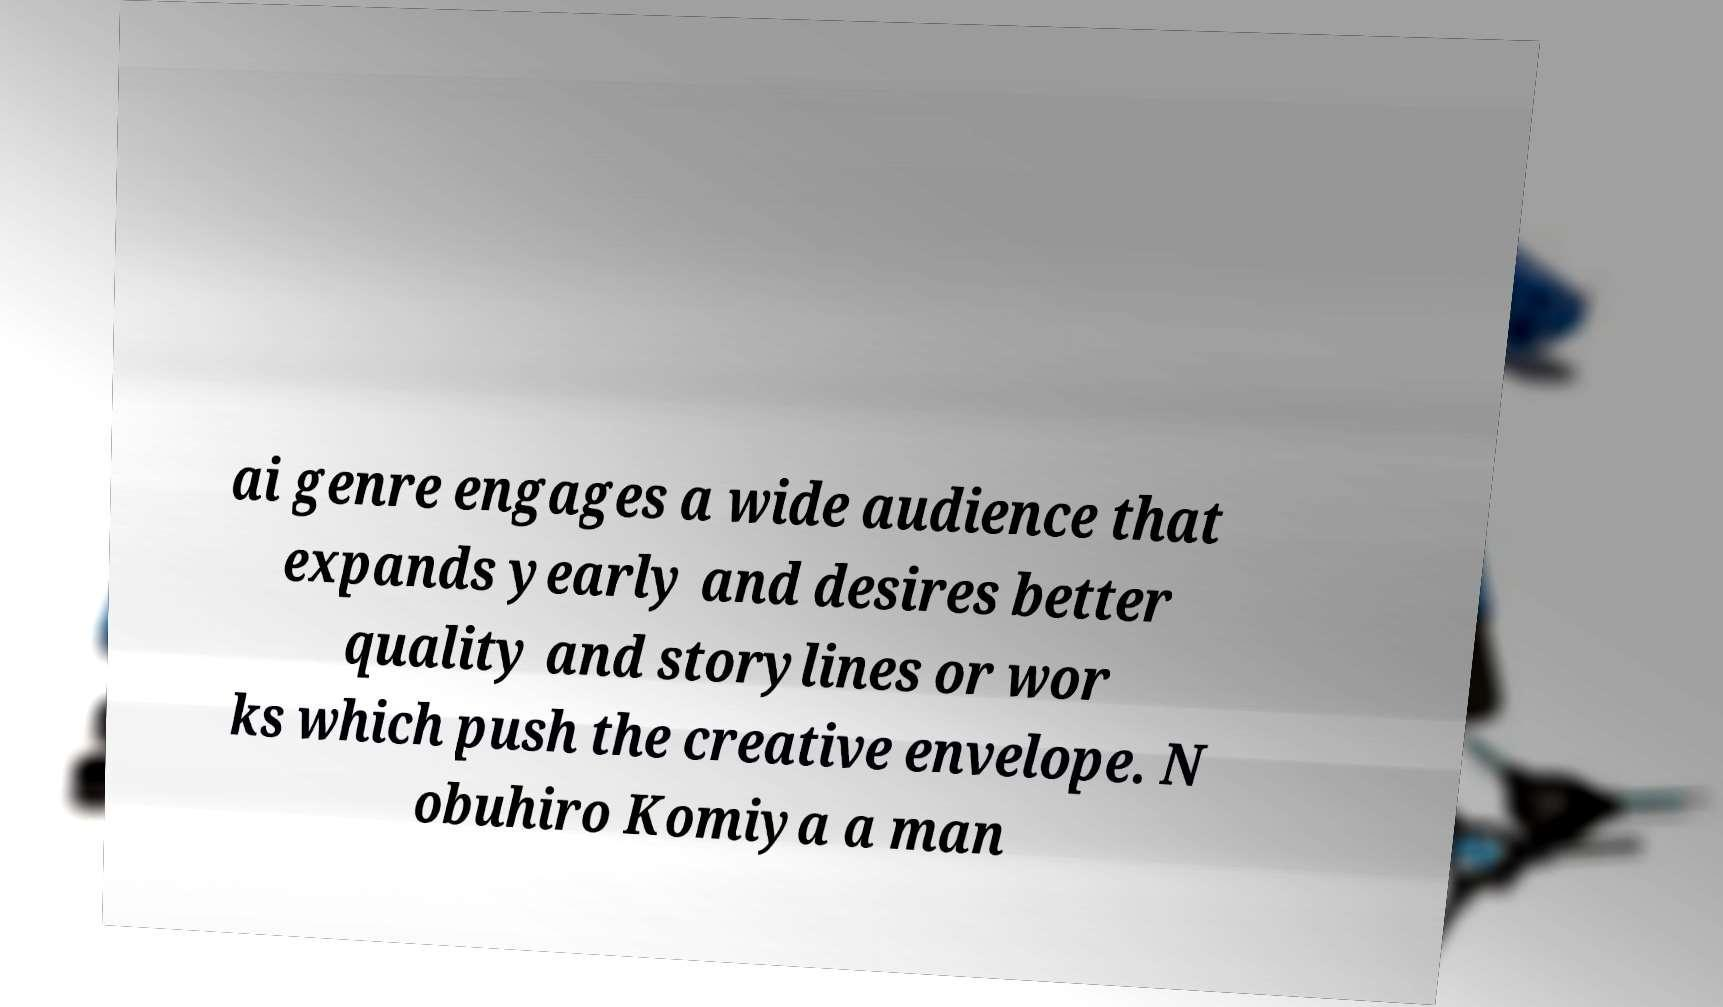Can you read and provide the text displayed in the image?This photo seems to have some interesting text. Can you extract and type it out for me? ai genre engages a wide audience that expands yearly and desires better quality and storylines or wor ks which push the creative envelope. N obuhiro Komiya a man 